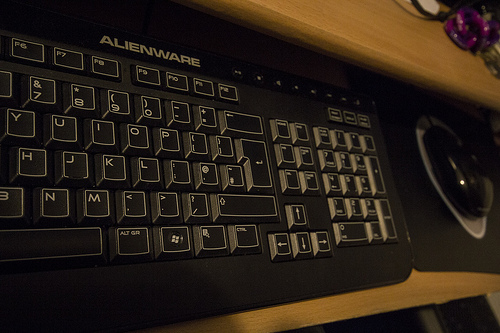What is the piece of furniture in the image? The image showcases a computer desk, typically used to support computer hardware and provide a comfortable typing surface for users. 